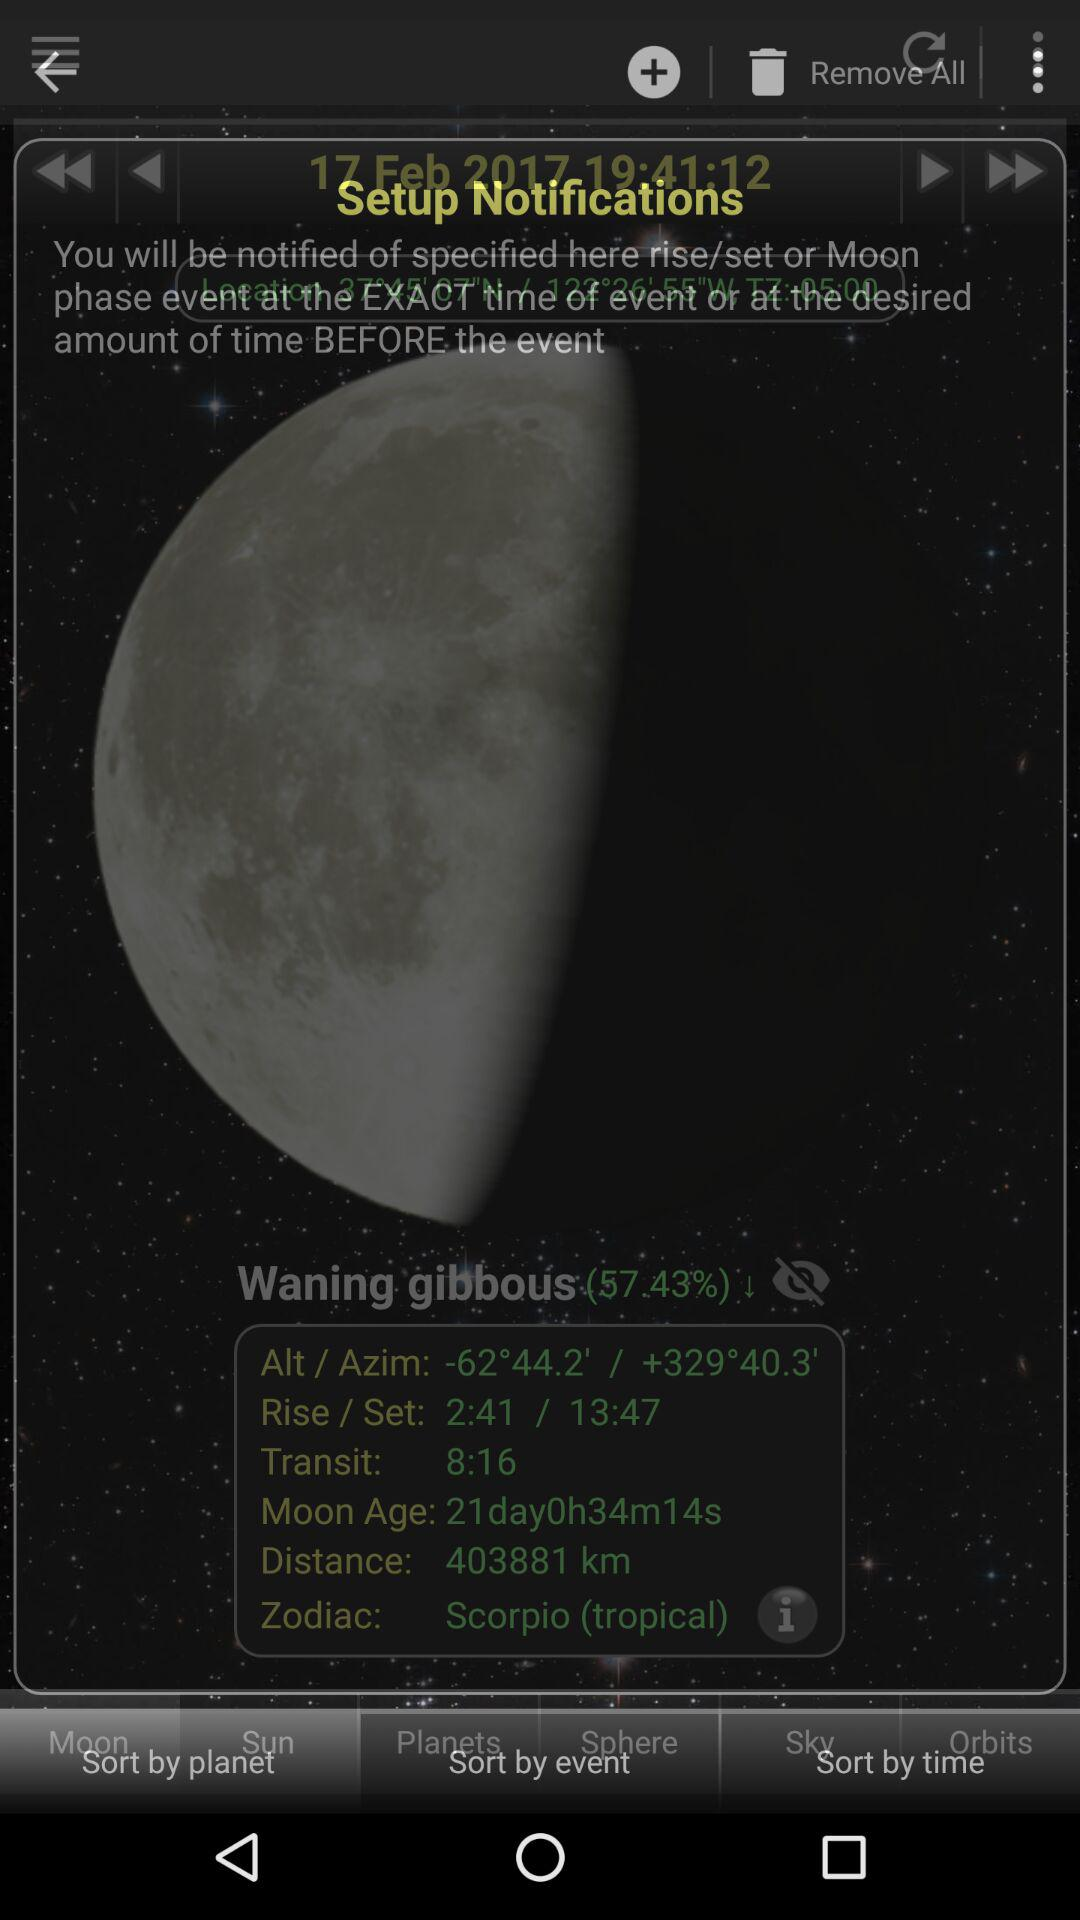When will the moon be full?
When the provided information is insufficient, respond with <no answer>. <no answer> 